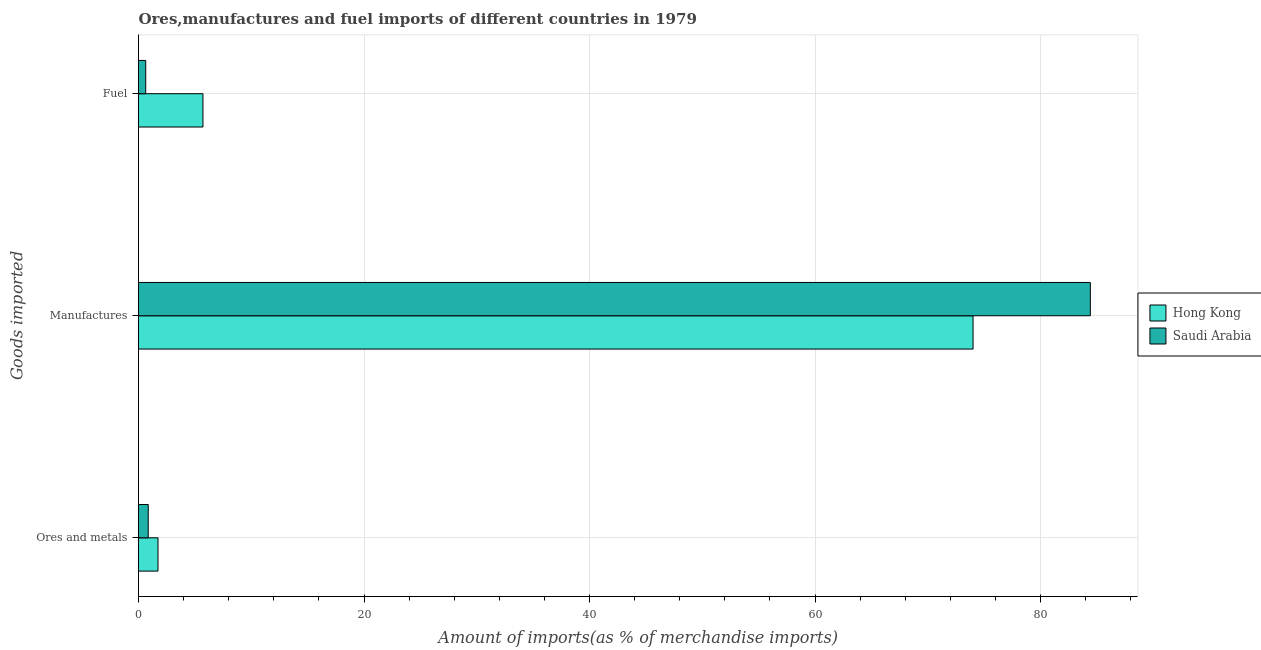How many different coloured bars are there?
Give a very brief answer. 2. What is the label of the 3rd group of bars from the top?
Offer a very short reply. Ores and metals. What is the percentage of manufactures imports in Hong Kong?
Your response must be concise. 74.02. Across all countries, what is the maximum percentage of ores and metals imports?
Provide a succinct answer. 1.73. Across all countries, what is the minimum percentage of ores and metals imports?
Offer a very short reply. 0.86. In which country was the percentage of fuel imports maximum?
Provide a short and direct response. Hong Kong. In which country was the percentage of manufactures imports minimum?
Offer a very short reply. Hong Kong. What is the total percentage of ores and metals imports in the graph?
Your response must be concise. 2.59. What is the difference between the percentage of manufactures imports in Saudi Arabia and that in Hong Kong?
Your answer should be compact. 10.4. What is the difference between the percentage of ores and metals imports in Hong Kong and the percentage of fuel imports in Saudi Arabia?
Your response must be concise. 1.09. What is the average percentage of fuel imports per country?
Your answer should be very brief. 3.18. What is the difference between the percentage of manufactures imports and percentage of ores and metals imports in Saudi Arabia?
Keep it short and to the point. 83.56. In how many countries, is the percentage of fuel imports greater than 24 %?
Provide a short and direct response. 0. What is the ratio of the percentage of ores and metals imports in Hong Kong to that in Saudi Arabia?
Your answer should be very brief. 2. Is the difference between the percentage of ores and metals imports in Hong Kong and Saudi Arabia greater than the difference between the percentage of manufactures imports in Hong Kong and Saudi Arabia?
Your answer should be very brief. Yes. What is the difference between the highest and the second highest percentage of fuel imports?
Provide a short and direct response. 5.08. What is the difference between the highest and the lowest percentage of manufactures imports?
Your response must be concise. 10.4. What does the 1st bar from the top in Ores and metals represents?
Your response must be concise. Saudi Arabia. What does the 1st bar from the bottom in Fuel represents?
Keep it short and to the point. Hong Kong. Are all the bars in the graph horizontal?
Keep it short and to the point. Yes. What is the difference between two consecutive major ticks on the X-axis?
Your response must be concise. 20. Are the values on the major ticks of X-axis written in scientific E-notation?
Give a very brief answer. No. Does the graph contain any zero values?
Keep it short and to the point. No. How many legend labels are there?
Offer a terse response. 2. How are the legend labels stacked?
Keep it short and to the point. Vertical. What is the title of the graph?
Make the answer very short. Ores,manufactures and fuel imports of different countries in 1979. Does "Tunisia" appear as one of the legend labels in the graph?
Give a very brief answer. No. What is the label or title of the X-axis?
Make the answer very short. Amount of imports(as % of merchandise imports). What is the label or title of the Y-axis?
Keep it short and to the point. Goods imported. What is the Amount of imports(as % of merchandise imports) in Hong Kong in Ores and metals?
Provide a short and direct response. 1.73. What is the Amount of imports(as % of merchandise imports) of Saudi Arabia in Ores and metals?
Offer a terse response. 0.86. What is the Amount of imports(as % of merchandise imports) in Hong Kong in Manufactures?
Ensure brevity in your answer.  74.02. What is the Amount of imports(as % of merchandise imports) of Saudi Arabia in Manufactures?
Your answer should be very brief. 84.42. What is the Amount of imports(as % of merchandise imports) of Hong Kong in Fuel?
Your response must be concise. 5.72. What is the Amount of imports(as % of merchandise imports) of Saudi Arabia in Fuel?
Provide a short and direct response. 0.64. Across all Goods imported, what is the maximum Amount of imports(as % of merchandise imports) in Hong Kong?
Give a very brief answer. 74.02. Across all Goods imported, what is the maximum Amount of imports(as % of merchandise imports) in Saudi Arabia?
Ensure brevity in your answer.  84.42. Across all Goods imported, what is the minimum Amount of imports(as % of merchandise imports) of Hong Kong?
Provide a short and direct response. 1.73. Across all Goods imported, what is the minimum Amount of imports(as % of merchandise imports) of Saudi Arabia?
Offer a terse response. 0.64. What is the total Amount of imports(as % of merchandise imports) in Hong Kong in the graph?
Keep it short and to the point. 81.46. What is the total Amount of imports(as % of merchandise imports) of Saudi Arabia in the graph?
Make the answer very short. 85.92. What is the difference between the Amount of imports(as % of merchandise imports) of Hong Kong in Ores and metals and that in Manufactures?
Offer a very short reply. -72.29. What is the difference between the Amount of imports(as % of merchandise imports) of Saudi Arabia in Ores and metals and that in Manufactures?
Offer a very short reply. -83.56. What is the difference between the Amount of imports(as % of merchandise imports) of Hong Kong in Ores and metals and that in Fuel?
Your response must be concise. -3.99. What is the difference between the Amount of imports(as % of merchandise imports) of Saudi Arabia in Ores and metals and that in Fuel?
Offer a terse response. 0.22. What is the difference between the Amount of imports(as % of merchandise imports) in Hong Kong in Manufactures and that in Fuel?
Offer a very short reply. 68.3. What is the difference between the Amount of imports(as % of merchandise imports) in Saudi Arabia in Manufactures and that in Fuel?
Provide a short and direct response. 83.78. What is the difference between the Amount of imports(as % of merchandise imports) in Hong Kong in Ores and metals and the Amount of imports(as % of merchandise imports) in Saudi Arabia in Manufactures?
Ensure brevity in your answer.  -82.69. What is the difference between the Amount of imports(as % of merchandise imports) in Hong Kong in Ores and metals and the Amount of imports(as % of merchandise imports) in Saudi Arabia in Fuel?
Your response must be concise. 1.09. What is the difference between the Amount of imports(as % of merchandise imports) in Hong Kong in Manufactures and the Amount of imports(as % of merchandise imports) in Saudi Arabia in Fuel?
Your response must be concise. 73.38. What is the average Amount of imports(as % of merchandise imports) in Hong Kong per Goods imported?
Make the answer very short. 27.15. What is the average Amount of imports(as % of merchandise imports) in Saudi Arabia per Goods imported?
Your answer should be very brief. 28.64. What is the difference between the Amount of imports(as % of merchandise imports) of Hong Kong and Amount of imports(as % of merchandise imports) of Saudi Arabia in Ores and metals?
Give a very brief answer. 0.87. What is the difference between the Amount of imports(as % of merchandise imports) of Hong Kong and Amount of imports(as % of merchandise imports) of Saudi Arabia in Manufactures?
Your answer should be very brief. -10.4. What is the difference between the Amount of imports(as % of merchandise imports) of Hong Kong and Amount of imports(as % of merchandise imports) of Saudi Arabia in Fuel?
Offer a terse response. 5.08. What is the ratio of the Amount of imports(as % of merchandise imports) of Hong Kong in Ores and metals to that in Manufactures?
Offer a very short reply. 0.02. What is the ratio of the Amount of imports(as % of merchandise imports) in Saudi Arabia in Ores and metals to that in Manufactures?
Your answer should be compact. 0.01. What is the ratio of the Amount of imports(as % of merchandise imports) of Hong Kong in Ores and metals to that in Fuel?
Provide a short and direct response. 0.3. What is the ratio of the Amount of imports(as % of merchandise imports) in Saudi Arabia in Ores and metals to that in Fuel?
Give a very brief answer. 1.35. What is the ratio of the Amount of imports(as % of merchandise imports) in Hong Kong in Manufactures to that in Fuel?
Your answer should be compact. 12.95. What is the ratio of the Amount of imports(as % of merchandise imports) in Saudi Arabia in Manufactures to that in Fuel?
Offer a terse response. 132.1. What is the difference between the highest and the second highest Amount of imports(as % of merchandise imports) in Hong Kong?
Your answer should be very brief. 68.3. What is the difference between the highest and the second highest Amount of imports(as % of merchandise imports) in Saudi Arabia?
Ensure brevity in your answer.  83.56. What is the difference between the highest and the lowest Amount of imports(as % of merchandise imports) in Hong Kong?
Provide a short and direct response. 72.29. What is the difference between the highest and the lowest Amount of imports(as % of merchandise imports) of Saudi Arabia?
Provide a succinct answer. 83.78. 